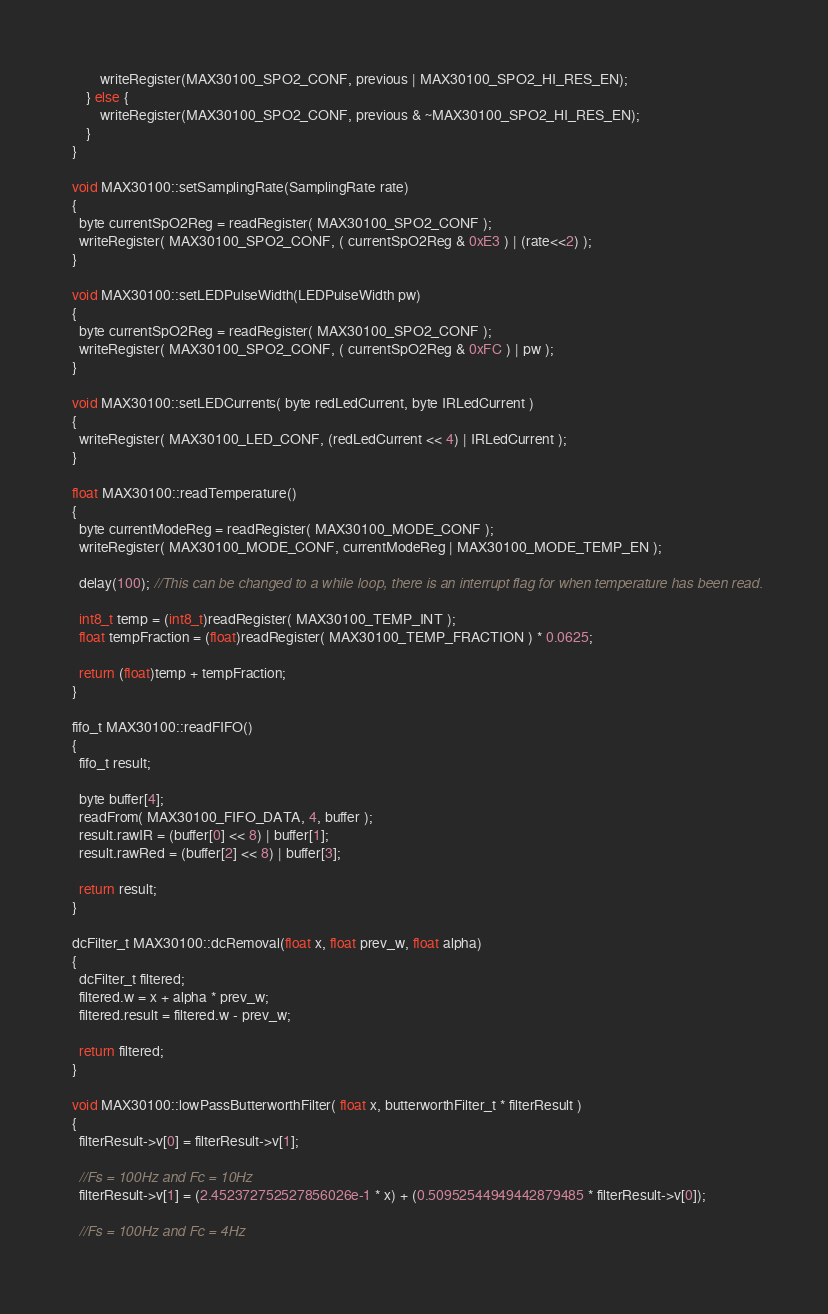Convert code to text. <code><loc_0><loc_0><loc_500><loc_500><_C++_>        writeRegister(MAX30100_SPO2_CONF, previous | MAX30100_SPO2_HI_RES_EN);
    } else {
        writeRegister(MAX30100_SPO2_CONF, previous & ~MAX30100_SPO2_HI_RES_EN);
    }
}

void MAX30100::setSamplingRate(SamplingRate rate)
{
  byte currentSpO2Reg = readRegister( MAX30100_SPO2_CONF );
  writeRegister( MAX30100_SPO2_CONF, ( currentSpO2Reg & 0xE3 ) | (rate<<2) );
}

void MAX30100::setLEDPulseWidth(LEDPulseWidth pw)
{
  byte currentSpO2Reg = readRegister( MAX30100_SPO2_CONF );
  writeRegister( MAX30100_SPO2_CONF, ( currentSpO2Reg & 0xFC ) | pw );
}

void MAX30100::setLEDCurrents( byte redLedCurrent, byte IRLedCurrent )
{
  writeRegister( MAX30100_LED_CONF, (redLedCurrent << 4) | IRLedCurrent );
}

float MAX30100::readTemperature()
{
  byte currentModeReg = readRegister( MAX30100_MODE_CONF );
  writeRegister( MAX30100_MODE_CONF, currentModeReg | MAX30100_MODE_TEMP_EN );

  delay(100); //This can be changed to a while loop, there is an interrupt flag for when temperature has been read.

  int8_t temp = (int8_t)readRegister( MAX30100_TEMP_INT );
  float tempFraction = (float)readRegister( MAX30100_TEMP_FRACTION ) * 0.0625;

  return (float)temp + tempFraction;
}

fifo_t MAX30100::readFIFO()
{
  fifo_t result;

  byte buffer[4];
  readFrom( MAX30100_FIFO_DATA, 4, buffer );
  result.rawIR = (buffer[0] << 8) | buffer[1];
  result.rawRed = (buffer[2] << 8) | buffer[3];

  return result;
}

dcFilter_t MAX30100::dcRemoval(float x, float prev_w, float alpha)
{
  dcFilter_t filtered;
  filtered.w = x + alpha * prev_w;
  filtered.result = filtered.w - prev_w;

  return filtered;
}

void MAX30100::lowPassButterworthFilter( float x, butterworthFilter_t * filterResult )
{  
  filterResult->v[0] = filterResult->v[1];

  //Fs = 100Hz and Fc = 10Hz
  filterResult->v[1] = (2.452372752527856026e-1 * x) + (0.50952544949442879485 * filterResult->v[0]);

  //Fs = 100Hz and Fc = 4Hz</code> 